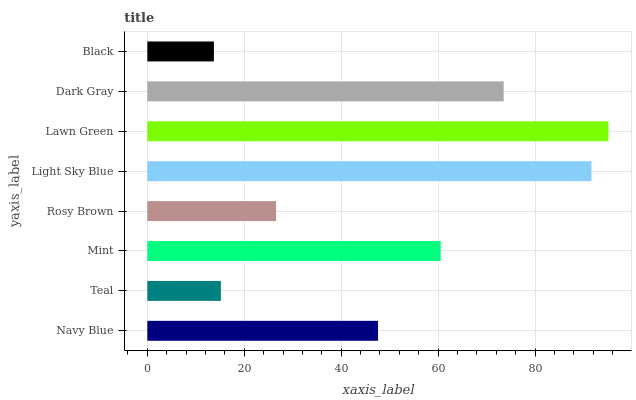Is Black the minimum?
Answer yes or no. Yes. Is Lawn Green the maximum?
Answer yes or no. Yes. Is Teal the minimum?
Answer yes or no. No. Is Teal the maximum?
Answer yes or no. No. Is Navy Blue greater than Teal?
Answer yes or no. Yes. Is Teal less than Navy Blue?
Answer yes or no. Yes. Is Teal greater than Navy Blue?
Answer yes or no. No. Is Navy Blue less than Teal?
Answer yes or no. No. Is Mint the high median?
Answer yes or no. Yes. Is Navy Blue the low median?
Answer yes or no. Yes. Is Light Sky Blue the high median?
Answer yes or no. No. Is Lawn Green the low median?
Answer yes or no. No. 